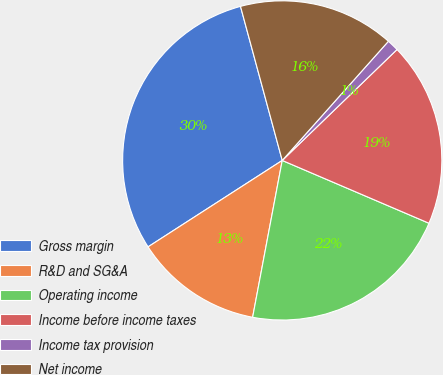Convert chart. <chart><loc_0><loc_0><loc_500><loc_500><pie_chart><fcel>Gross margin<fcel>R&D and SG&A<fcel>Operating income<fcel>Income before income taxes<fcel>Income tax provision<fcel>Net income<nl><fcel>29.89%<fcel>12.92%<fcel>21.53%<fcel>18.66%<fcel>1.19%<fcel>15.79%<nl></chart> 